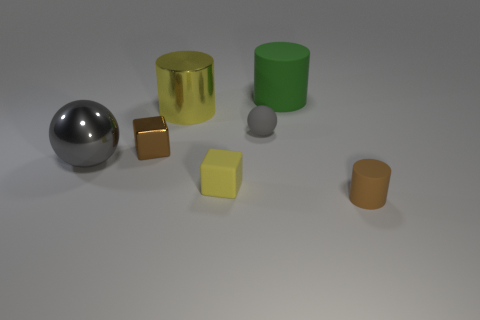Subtract all metallic cylinders. How many cylinders are left? 2 Add 2 large gray metallic objects. How many objects exist? 9 Subtract all green cylinders. How many cylinders are left? 2 Subtract all cubes. How many objects are left? 5 Subtract 2 cubes. How many cubes are left? 0 Subtract all green blocks. Subtract all blue balls. How many blocks are left? 2 Subtract all purple cylinders. How many brown blocks are left? 1 Subtract all small balls. Subtract all big cylinders. How many objects are left? 4 Add 2 metallic cylinders. How many metallic cylinders are left? 3 Add 1 tiny gray rubber objects. How many tiny gray rubber objects exist? 2 